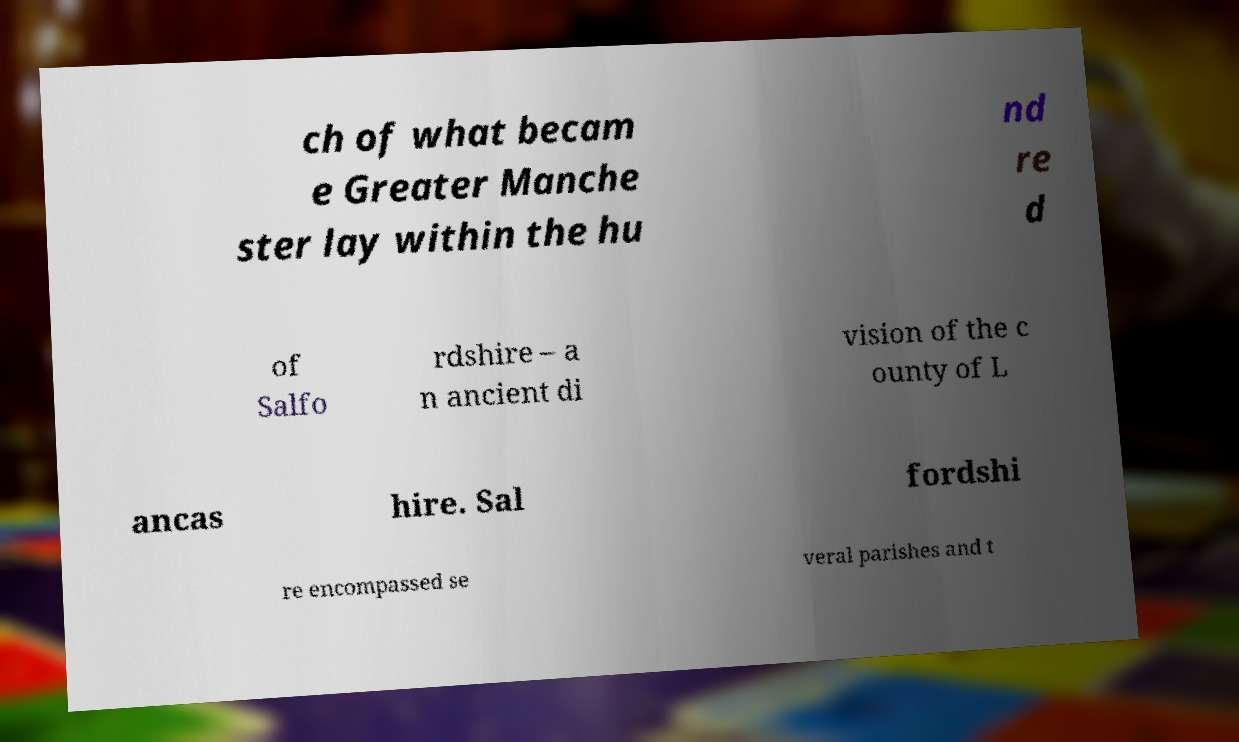Please identify and transcribe the text found in this image. ch of what becam e Greater Manche ster lay within the hu nd re d of Salfo rdshire – a n ancient di vision of the c ounty of L ancas hire. Sal fordshi re encompassed se veral parishes and t 